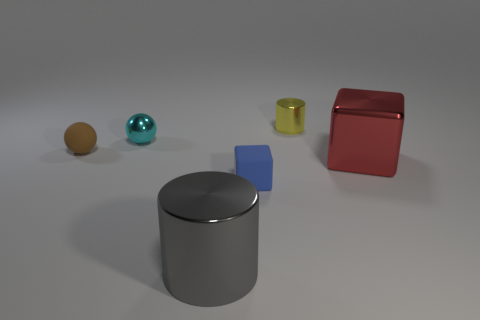Add 3 yellow cylinders. How many objects exist? 9 Subtract all cylinders. How many objects are left? 4 Subtract 0 yellow balls. How many objects are left? 6 Subtract all gray spheres. Subtract all big red metal things. How many objects are left? 5 Add 4 blue rubber objects. How many blue rubber objects are left? 5 Add 4 cyan balls. How many cyan balls exist? 5 